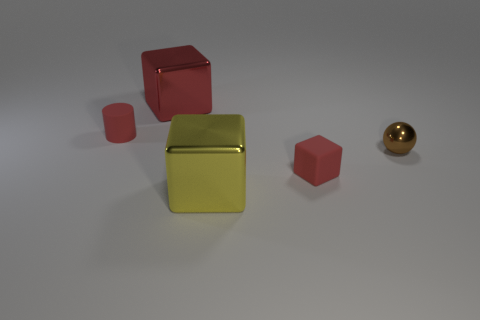The matte cylinder has what color?
Give a very brief answer. Red. Do the red rubber thing to the left of the yellow block and the small red matte object that is in front of the small brown sphere have the same shape?
Offer a terse response. No. What color is the big metal cube in front of the rubber cylinder?
Your answer should be compact. Yellow. Are there fewer tiny red matte things that are behind the big red cube than large red things that are behind the small sphere?
Offer a terse response. Yes. What number of other things are there of the same material as the tiny block
Offer a terse response. 1. Are the yellow block and the large red thing made of the same material?
Make the answer very short. Yes. What number of other things are the same size as the rubber block?
Offer a terse response. 2. Is the number of red cylinders the same as the number of purple metal cubes?
Ensure brevity in your answer.  No. There is a cube that is behind the tiny rubber thing on the left side of the red metallic cube; how big is it?
Your answer should be very brief. Large. What is the color of the tiny thing behind the brown shiny object in front of the small red rubber thing to the left of the red metal thing?
Give a very brief answer. Red. 